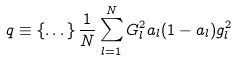<formula> <loc_0><loc_0><loc_500><loc_500>q \equiv \left \{ \dots \right \} \frac { 1 } { N } \sum _ { l = 1 } ^ { N } G _ { l } ^ { 2 } a _ { l } ( 1 - a _ { l } ) g _ { l } ^ { 2 }</formula> 